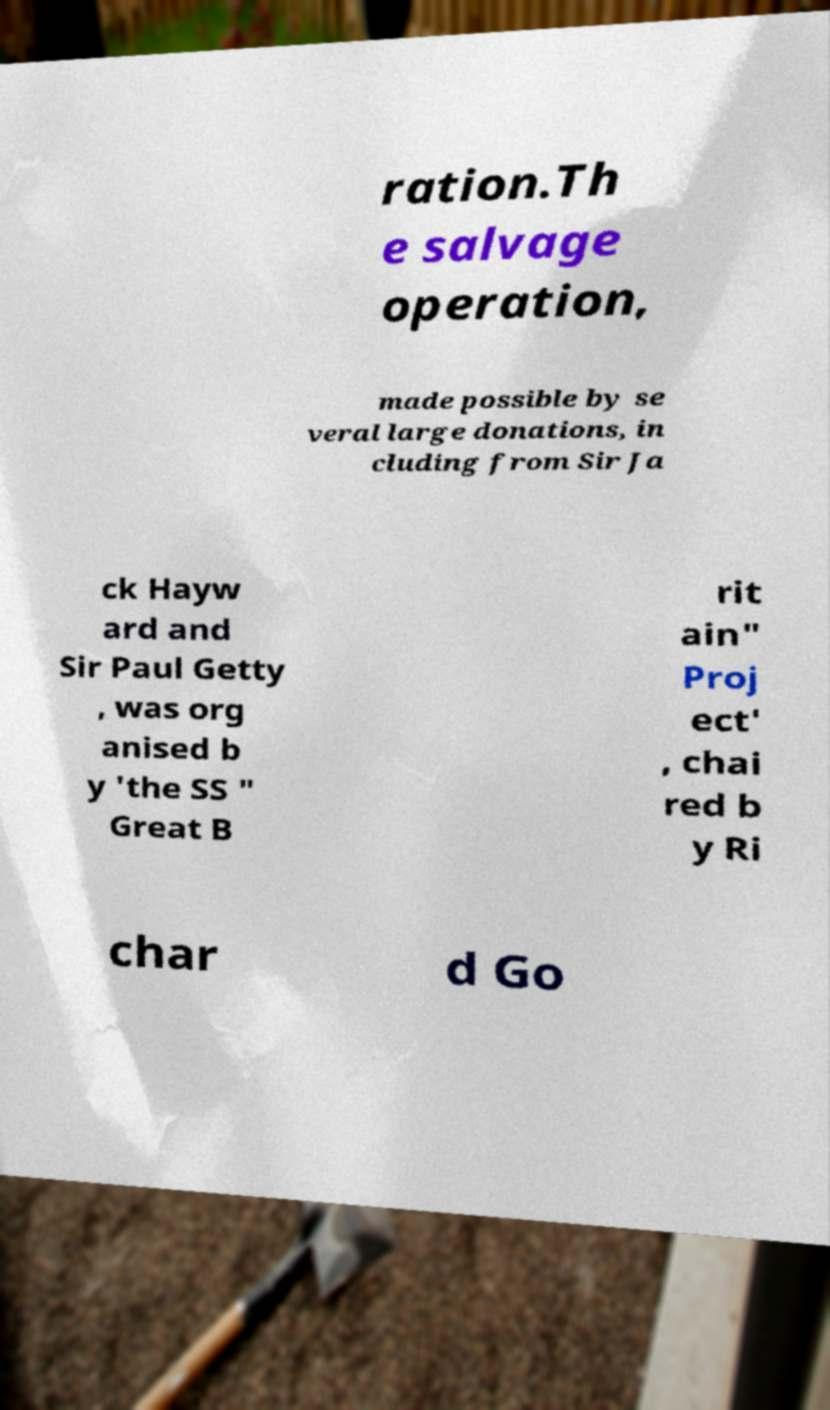Could you extract and type out the text from this image? ration.Th e salvage operation, made possible by se veral large donations, in cluding from Sir Ja ck Hayw ard and Sir Paul Getty , was org anised b y 'the SS " Great B rit ain" Proj ect' , chai red b y Ri char d Go 